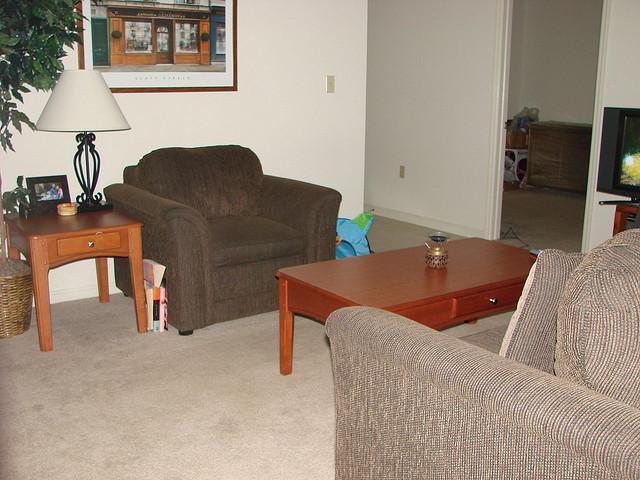How many chairs are there?
Give a very brief answer. 2. How many potted plants are in the picture?
Give a very brief answer. 1. 